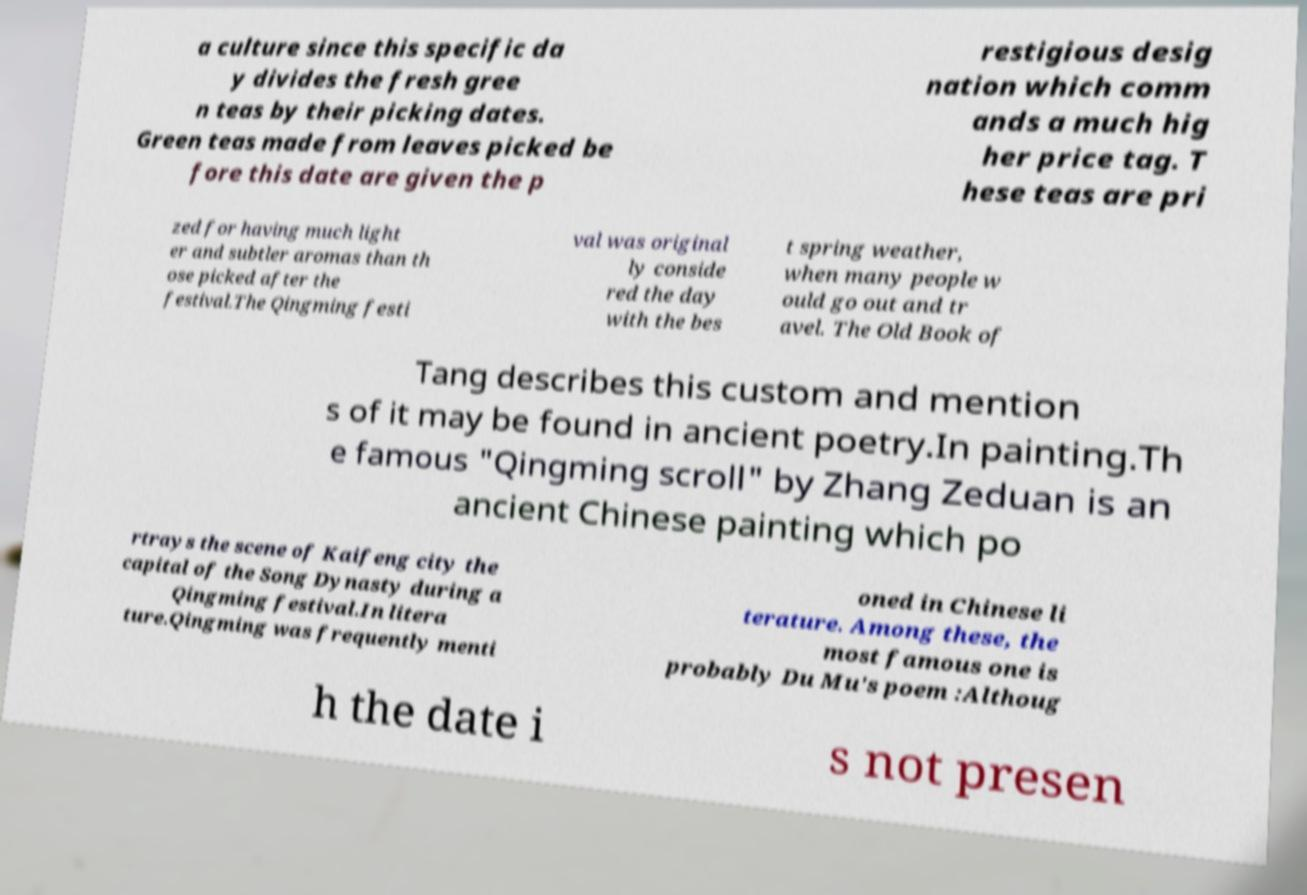There's text embedded in this image that I need extracted. Can you transcribe it verbatim? a culture since this specific da y divides the fresh gree n teas by their picking dates. Green teas made from leaves picked be fore this date are given the p restigious desig nation which comm ands a much hig her price tag. T hese teas are pri zed for having much light er and subtler aromas than th ose picked after the festival.The Qingming festi val was original ly conside red the day with the bes t spring weather, when many people w ould go out and tr avel. The Old Book of Tang describes this custom and mention s of it may be found in ancient poetry.In painting.Th e famous "Qingming scroll" by Zhang Zeduan is an ancient Chinese painting which po rtrays the scene of Kaifeng city the capital of the Song Dynasty during a Qingming festival.In litera ture.Qingming was frequently menti oned in Chinese li terature. Among these, the most famous one is probably Du Mu's poem :Althoug h the date i s not presen 